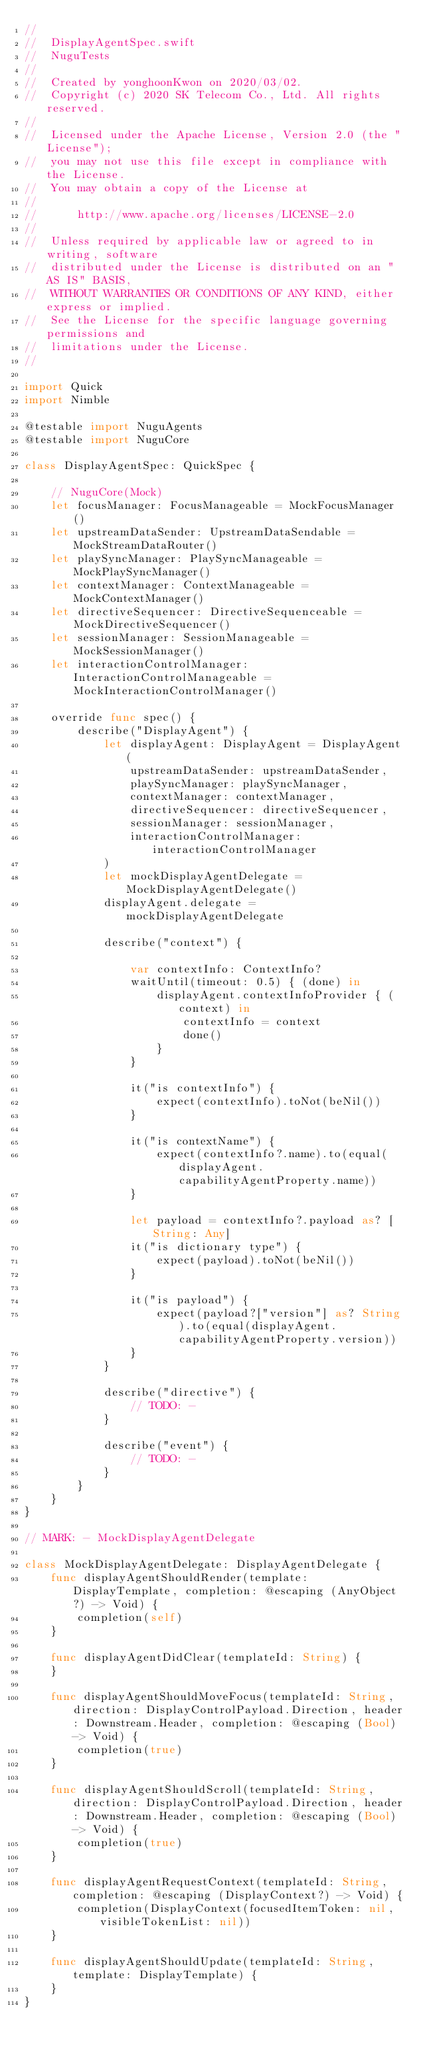Convert code to text. <code><loc_0><loc_0><loc_500><loc_500><_Swift_>//
//  DisplayAgentSpec.swift
//  NuguTests
//
//  Created by yonghoonKwon on 2020/03/02.
//  Copyright (c) 2020 SK Telecom Co., Ltd. All rights reserved.
//
//  Licensed under the Apache License, Version 2.0 (the "License");
//  you may not use this file except in compliance with the License.
//  You may obtain a copy of the License at
//
//      http://www.apache.org/licenses/LICENSE-2.0
//
//  Unless required by applicable law or agreed to in writing, software
//  distributed under the License is distributed on an "AS IS" BASIS,
//  WITHOUT WARRANTIES OR CONDITIONS OF ANY KIND, either express or implied.
//  See the License for the specific language governing permissions and
//  limitations under the License.
//

import Quick
import Nimble

@testable import NuguAgents
@testable import NuguCore

class DisplayAgentSpec: QuickSpec {
    
    // NuguCore(Mock)
    let focusManager: FocusManageable = MockFocusManager()
    let upstreamDataSender: UpstreamDataSendable = MockStreamDataRouter()
    let playSyncManager: PlaySyncManageable = MockPlaySyncManager()
    let contextManager: ContextManageable = MockContextManager()
    let directiveSequencer: DirectiveSequenceable = MockDirectiveSequencer()
    let sessionManager: SessionManageable = MockSessionManager()
    let interactionControlManager: InteractionControlManageable = MockInteractionControlManager()
    
    override func spec() {
        describe("DisplayAgent") {
            let displayAgent: DisplayAgent = DisplayAgent(
                upstreamDataSender: upstreamDataSender,
                playSyncManager: playSyncManager,
                contextManager: contextManager,
                directiveSequencer: directiveSequencer,
                sessionManager: sessionManager,
                interactionControlManager: interactionControlManager
            )
            let mockDisplayAgentDelegate = MockDisplayAgentDelegate()
            displayAgent.delegate = mockDisplayAgentDelegate
            
            describe("context") {
                
                var contextInfo: ContextInfo?
                waitUntil(timeout: 0.5) { (done) in
                    displayAgent.contextInfoProvider { (context) in
                        contextInfo = context
                        done()
                    }
                }
                
                it("is contextInfo") {
                    expect(contextInfo).toNot(beNil())
                }
                
                it("is contextName") {
                    expect(contextInfo?.name).to(equal(displayAgent.capabilityAgentProperty.name))
                }
                
                let payload = contextInfo?.payload as? [String: Any]
                it("is dictionary type") {
                    expect(payload).toNot(beNil())
                }
                
                it("is payload") {
                    expect(payload?["version"] as? String).to(equal(displayAgent.capabilityAgentProperty.version))
                }
            }
            
            describe("directive") {
                // TODO: -
            }
            
            describe("event") {
                // TODO: -
            }
        }
    }
}

// MARK: - MockDisplayAgentDelegate

class MockDisplayAgentDelegate: DisplayAgentDelegate {
    func displayAgentShouldRender(template: DisplayTemplate, completion: @escaping (AnyObject?) -> Void) {
        completion(self)
    }
    
    func displayAgentDidClear(templateId: String) {
    }
    
    func displayAgentShouldMoveFocus(templateId: String, direction: DisplayControlPayload.Direction, header: Downstream.Header, completion: @escaping (Bool) -> Void) {
        completion(true)
    }
    
    func displayAgentShouldScroll(templateId: String, direction: DisplayControlPayload.Direction, header: Downstream.Header, completion: @escaping (Bool) -> Void) {
        completion(true)
    }
    
    func displayAgentRequestContext(templateId: String, completion: @escaping (DisplayContext?) -> Void) {
        completion(DisplayContext(focusedItemToken: nil, visibleTokenList: nil))
    }
    
    func displayAgentShouldUpdate(templateId: String, template: DisplayTemplate) {
    }
}
</code> 